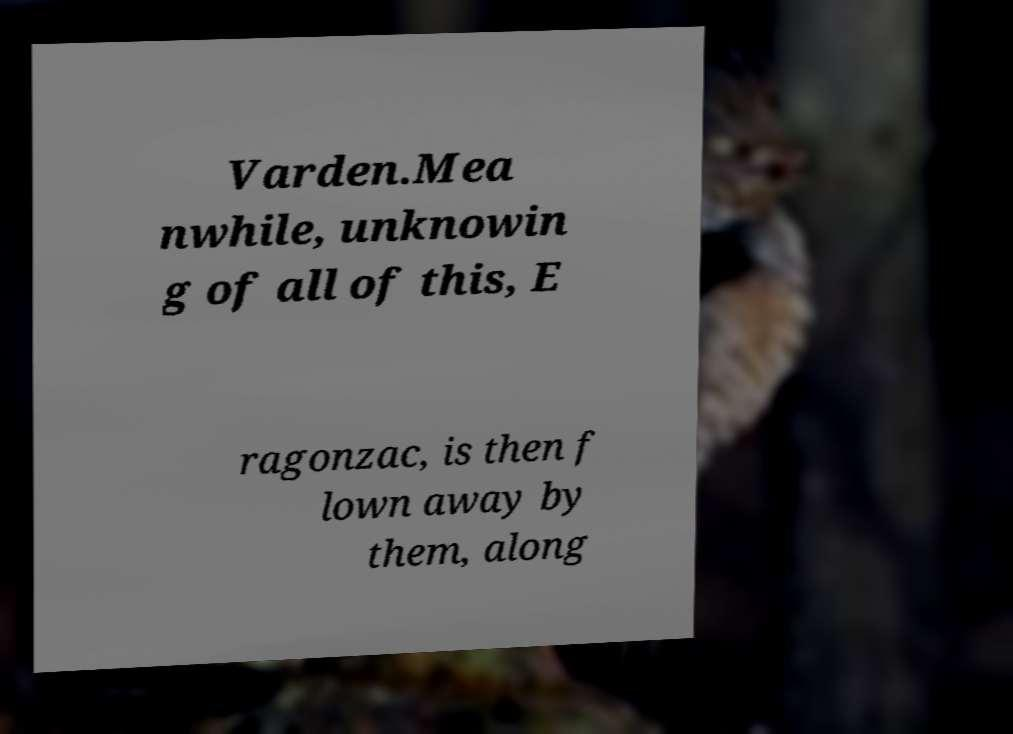There's text embedded in this image that I need extracted. Can you transcribe it verbatim? Varden.Mea nwhile, unknowin g of all of this, E ragonzac, is then f lown away by them, along 